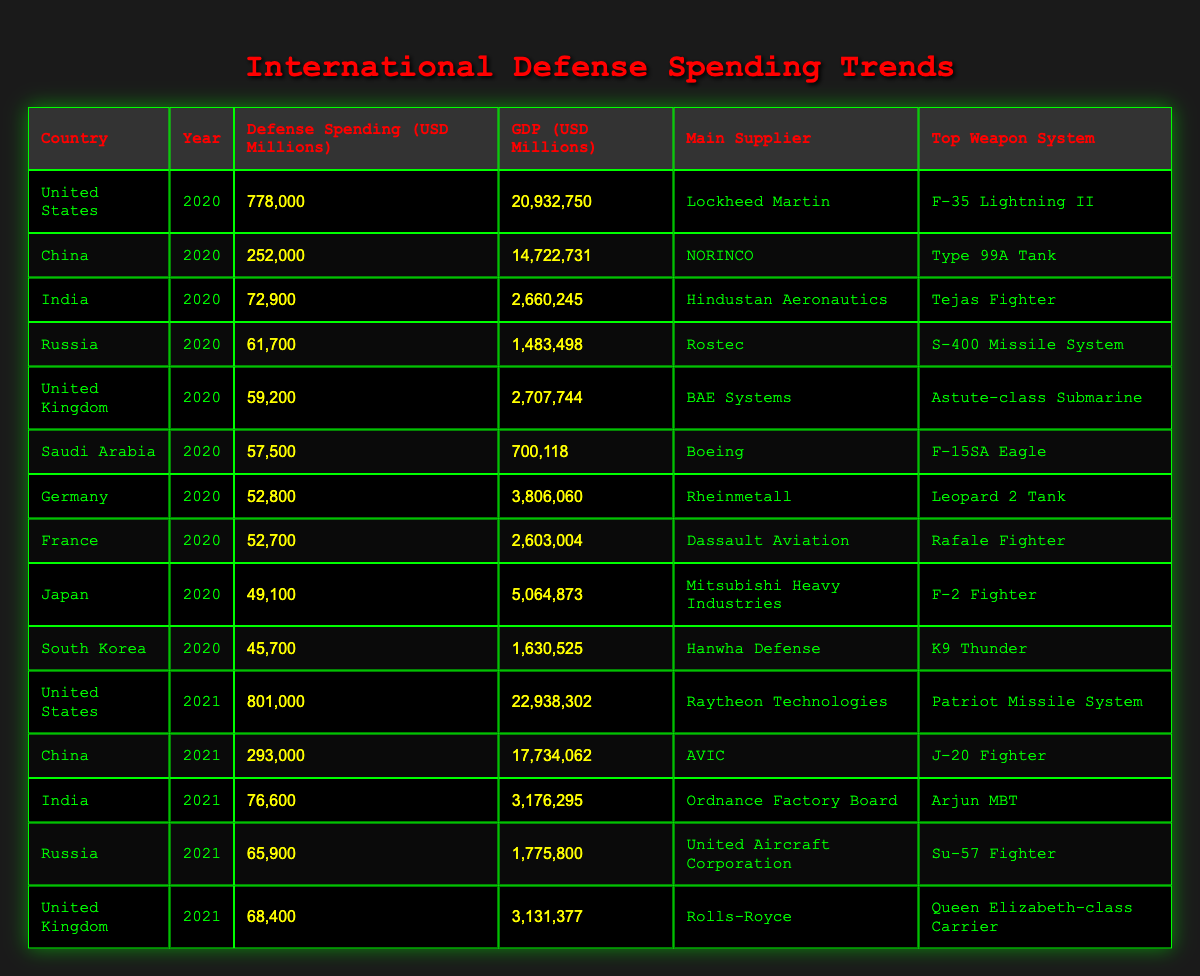What was the defense spending of the United States in 2021? In the table, I locate the row for the United States in the year 2021, which shows a defense spending of 801,000 million USD.
Answer: 801000 Which country had the highest defense spending in 2020? By reviewing the 2020 data, the United States has the highest defense spending at 778,000 million USD compared to the other countries listed.
Answer: United States What is the difference in defense spending between China in 2020 and 2021? First, I find China's defense spending for 2020, which is 252,000 million USD. Next, I find the spending for 2021, which is 293,000 million USD. The difference is calculated as 293,000 - 252,000 = 41,000 million USD.
Answer: 41000 Did Germany have a higher defense spending than France in 2021? Checking both countries for the year 2021, Germany's spending is not listed, while France's 2021 spending is 52,700 million USD. Since Germany's data for 2021 is absent, the answer is no.
Answer: No What is the average defense spending of the listed countries for the year 2020? For 2020, I sum the defense spending figures for the countries: 778,000 (US) + 252,000 (China) + 72,900 (India) + 61,700 (Russia) + 59,200 (UK) + 57,500 (Saudi Arabia) + 52,800 (Germany) + 52,700 (France) + 49,100 (Japan) + 45,700 (South Korea) = 1,392,100 million USD. There are 10 data points, so I divide the total by 10, resulting in an average of 139,210 million USD.
Answer: 139210 What was the main supplier for Russia in 2021? Upon reviewing the table, the row for Russia in 2021 shows that the main supplier is United Aircraft Corporation.
Answer: United Aircraft Corporation 